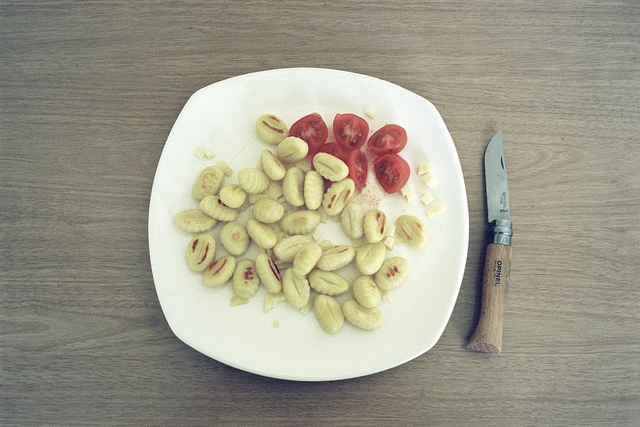Describe the objects in this image and their specific colors. I can see dining table in darkgray, gray, ivory, and khaki tones and knife in gray and darkgray tones in this image. 